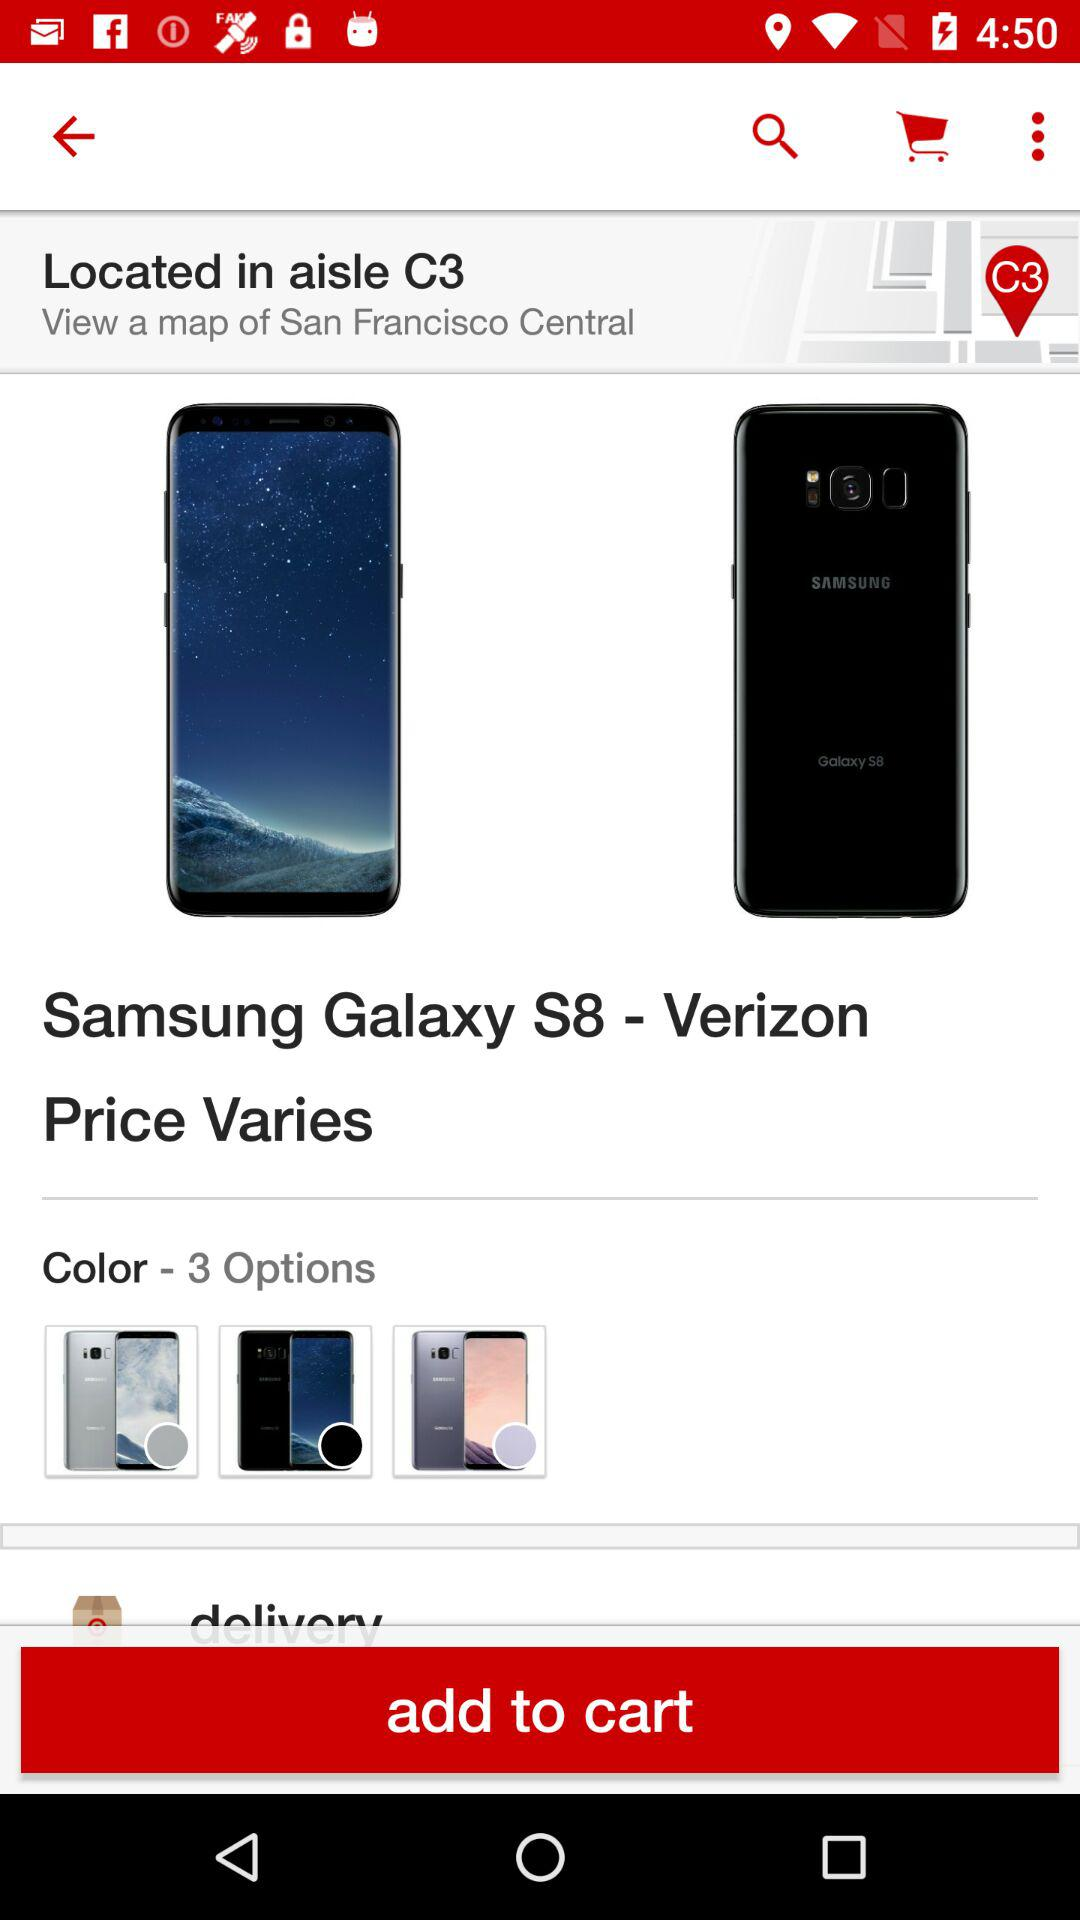Is there any Item in the cart?
When the provided information is insufficient, respond with <no answer>. <no answer> 